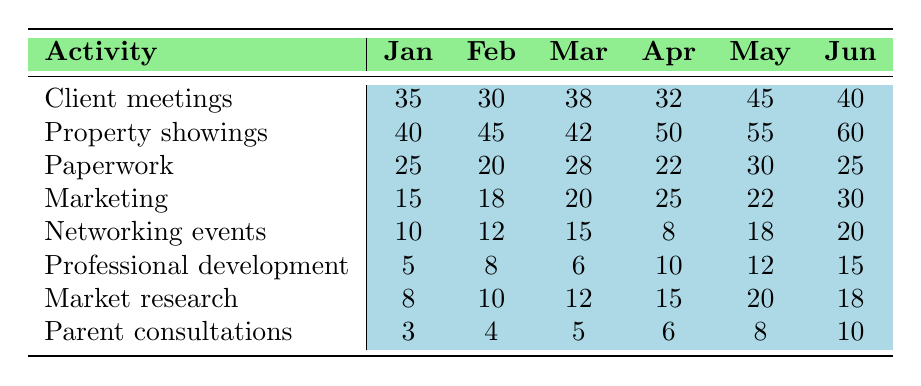What was the total number of hours spent on client meetings in March? The table shows that in March, the number of hours spent on client meetings was 38.
Answer: 38 What activity had the highest time spent in June? Looking at the June column, property showings had the highest time spent with 60 hours.
Answer: Property showings How many hours were spent on networking events across all months? By adding the hours for networking events from each month: 10 + 12 + 15 + 8 + 18 + 20 = 83 hours.
Answer: 83 What is the average time spent on paperwork over the six months? Summing the hours spent on paperwork gives 25 + 20 + 28 + 22 + 30 + 25 = 150. Then dividing by 6 months gives an average of 150/6 = 25 hours.
Answer: 25 Did the time spent on marketing increase in June compared to January? In January, 15 hours were spent on marketing, and in June, it increased to 30 hours. Therefore, the time increased.
Answer: Yes Which activity saw the smallest amount of time spent in February? In February, looking at the table, parent consultations had the smallest amount of time spent with 4 hours.
Answer: Parent consultations What is the difference in hours spent between property showings in May and networking events in April? For property showings in May, 55 hours were spent, and for networking events in April, 8 hours were spent. The difference is 55 - 8 = 47 hours.
Answer: 47 What was the total time spent on all activities in April? By summing the hours for each activity in April: 32 + 50 + 22 + 25 + 8 + 10 + 15 + 6 = 168 hours.
Answer: 168 How much more time was spent on professional development in June compared to January? In June, 15 hours were spent on professional development, while in January, only 5 hours were spent. The difference is 15 - 5 = 10 hours more in June.
Answer: 10 Was the total time spent on parent consultations consistent month over month? Analyzing the hours for parent consultations: 3, 4, 5, 6, 8, 10 shows a consistent increase each month, indicating it was not consistent.
Answer: No 